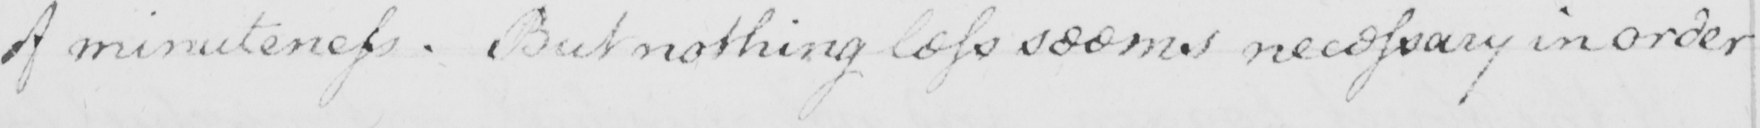Please transcribe the handwritten text in this image. of minuteness . But nothing less seems necessary in order 